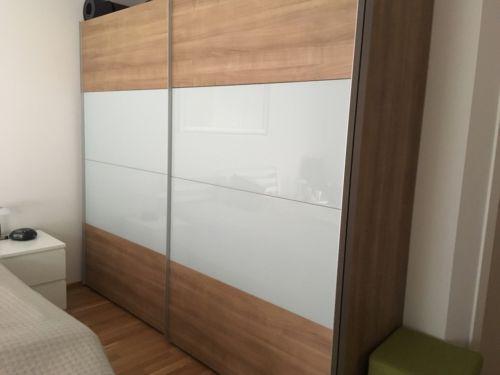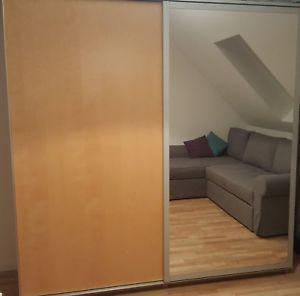The first image is the image on the left, the second image is the image on the right. Assess this claim about the two images: "One door is mirrored.". Correct or not? Answer yes or no. Yes. 